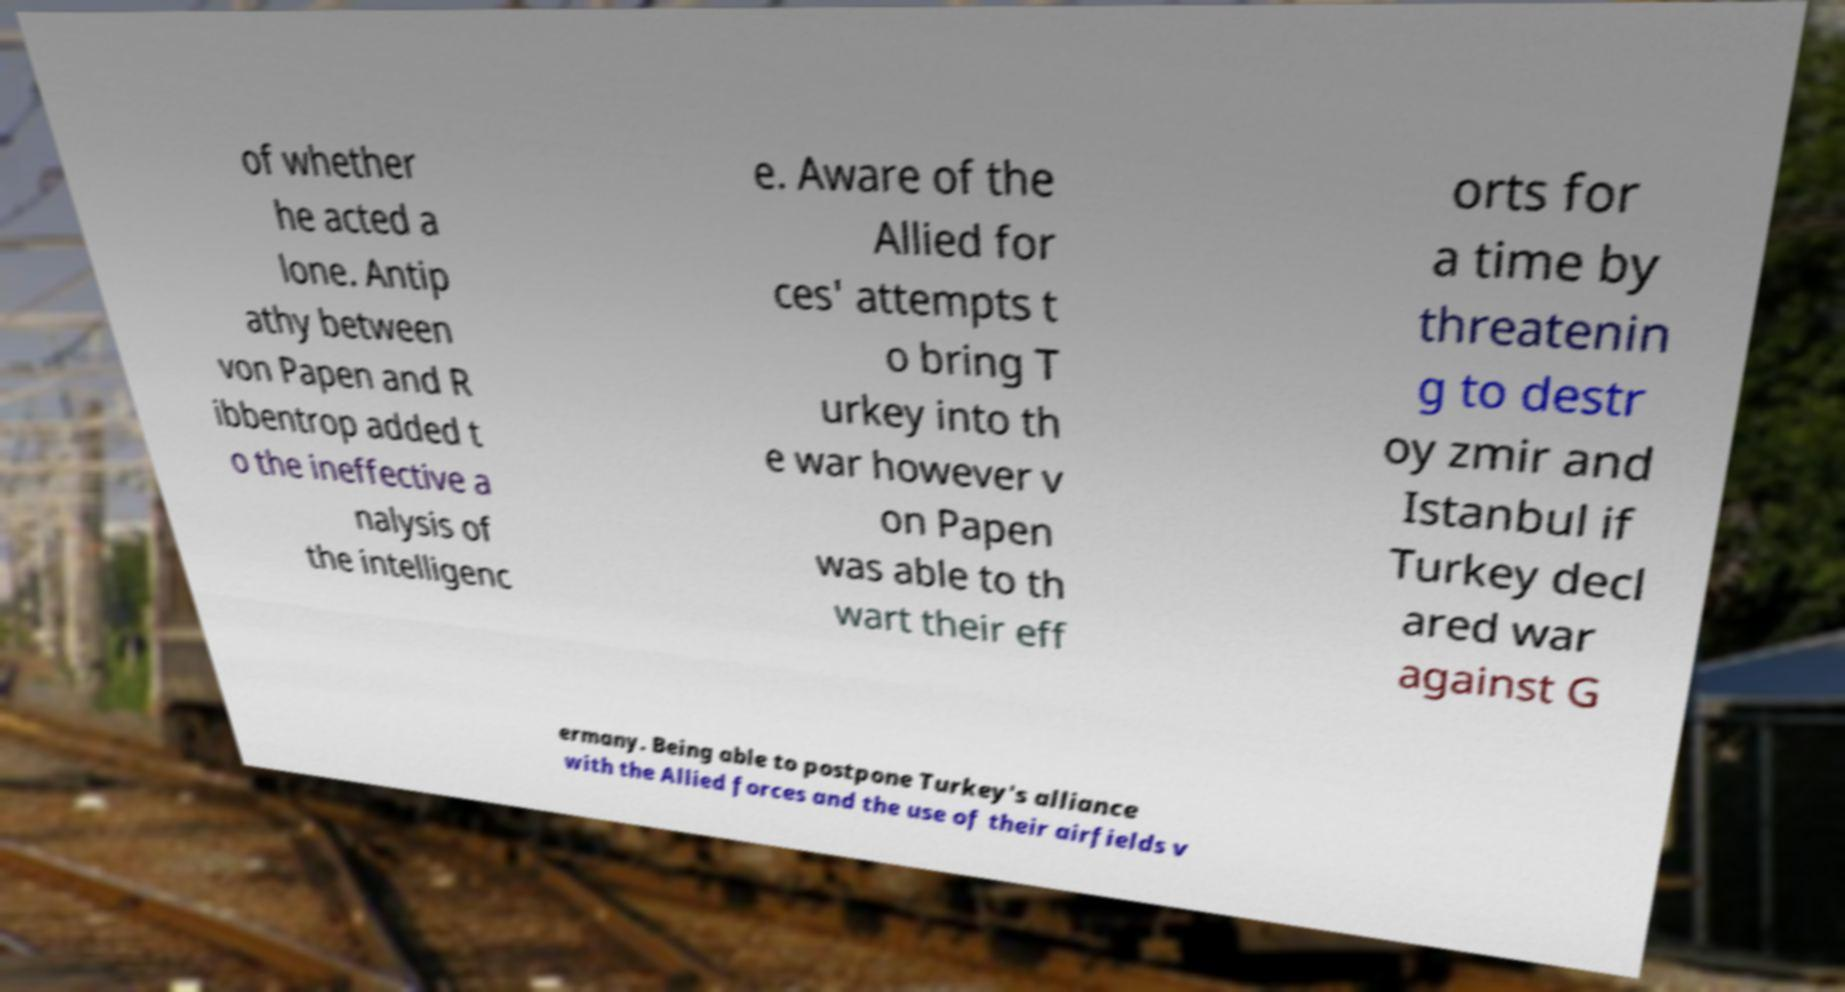Please identify and transcribe the text found in this image. of whether he acted a lone. Antip athy between von Papen and R ibbentrop added t o the ineffective a nalysis of the intelligenc e. Aware of the Allied for ces' attempts t o bring T urkey into th e war however v on Papen was able to th wart their eff orts for a time by threatenin g to destr oy zmir and Istanbul if Turkey decl ared war against G ermany. Being able to postpone Turkey's alliance with the Allied forces and the use of their airfields v 